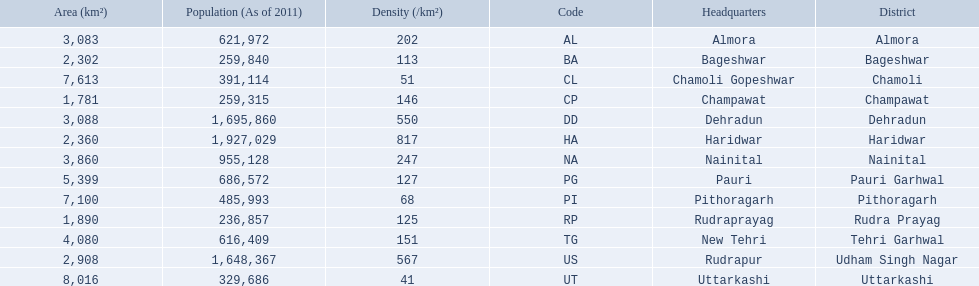What are the values for density of the districts of uttrakhand? 202, 113, 51, 146, 550, 817, 247, 127, 68, 125, 151, 567, 41. Which district has value of 51? Chamoli. 